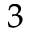Convert formula to latex. <formula><loc_0><loc_0><loc_500><loc_500>^ { 3 }</formula> 